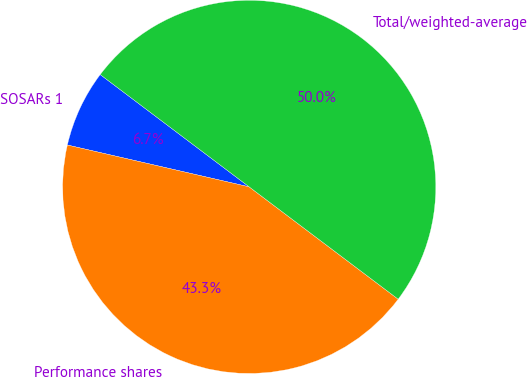Convert chart. <chart><loc_0><loc_0><loc_500><loc_500><pie_chart><fcel>SOSARs 1<fcel>Performance shares<fcel>Total/weighted-average<nl><fcel>6.68%<fcel>43.32%<fcel>50.0%<nl></chart> 